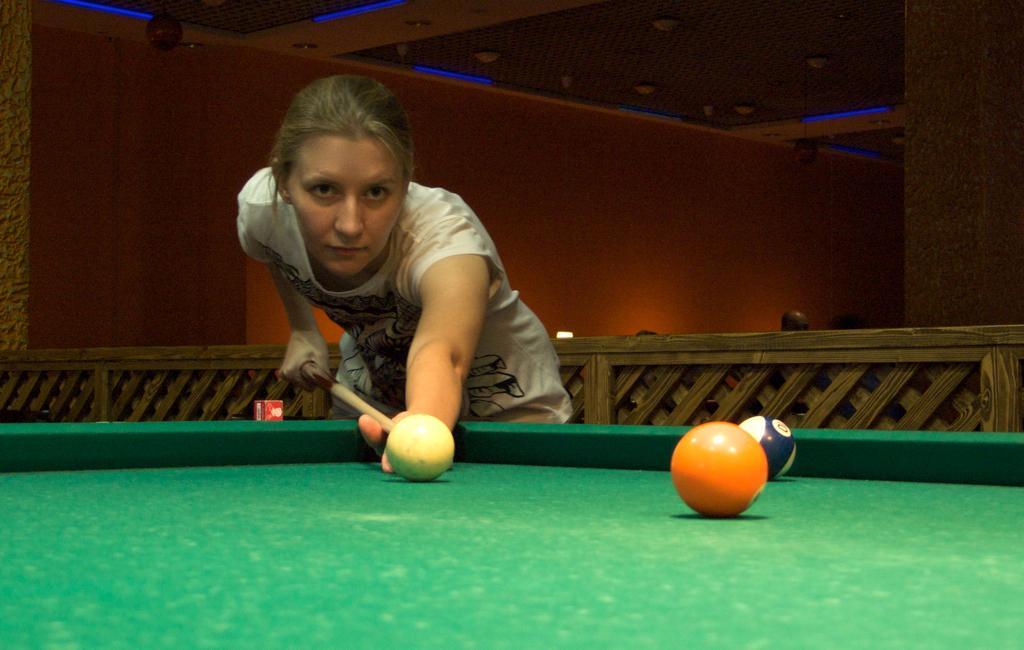Describe this image in one or two sentences. In this image there is a woman with white t-shirt, she is holding stick and she is playing the game. There are balls on the table. At the back there are two persons. At the top there are lights. 